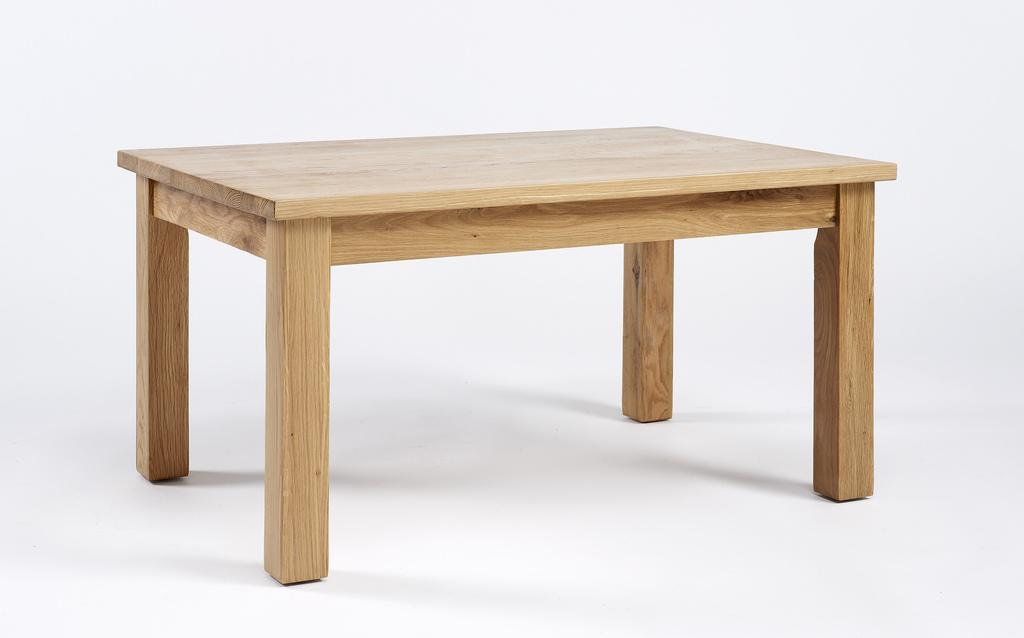What type of table is present in the image? There is a wooden table in the image. What color is the background of the image? The background of the image is white. What type of copper material can be seen on the table in the image? There is no copper material present on the table in the image. What type of fruit is visible on the ground in the image? There is no fruit or ground visible in the image. 